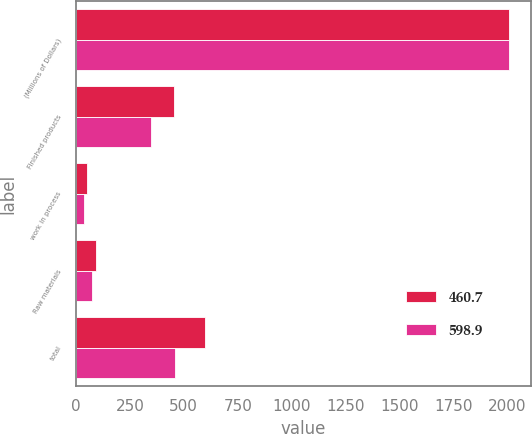Convert chart to OTSL. <chart><loc_0><loc_0><loc_500><loc_500><stacked_bar_chart><ecel><fcel>(Millions of Dollars)<fcel>Finished products<fcel>work in process<fcel>Raw materials<fcel>total<nl><fcel>460.7<fcel>2006<fcel>456.5<fcel>51<fcel>91.4<fcel>598.9<nl><fcel>598.9<fcel>2005<fcel>348.9<fcel>38.8<fcel>73<fcel>460.7<nl></chart> 